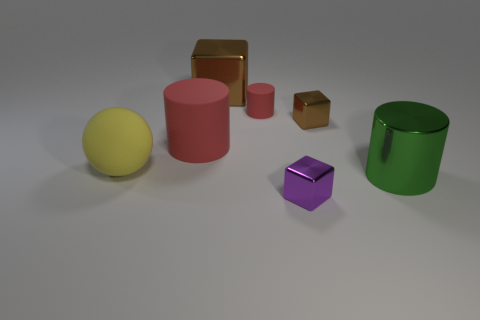There is a object behind the small thing to the left of the small cube that is in front of the green cylinder; what is its size?
Your response must be concise. Large. What number of other objects are there of the same shape as the purple thing?
Provide a short and direct response. 2. The object that is both right of the large brown object and behind the small brown metal cube is what color?
Your answer should be very brief. Red. Is the color of the matte cylinder that is behind the small brown block the same as the large ball?
Give a very brief answer. No. What number of balls are small brown objects or brown objects?
Offer a terse response. 0. What is the shape of the brown shiny object right of the small purple shiny object?
Provide a short and direct response. Cube. There is a cube in front of the small metallic thing behind the big matte object that is behind the yellow rubber thing; what color is it?
Keep it short and to the point. Purple. Do the tiny brown cube and the green cylinder have the same material?
Make the answer very short. Yes. How many yellow objects are large rubber cylinders or large things?
Offer a terse response. 1. What number of big yellow objects are to the left of the green cylinder?
Give a very brief answer. 1. 